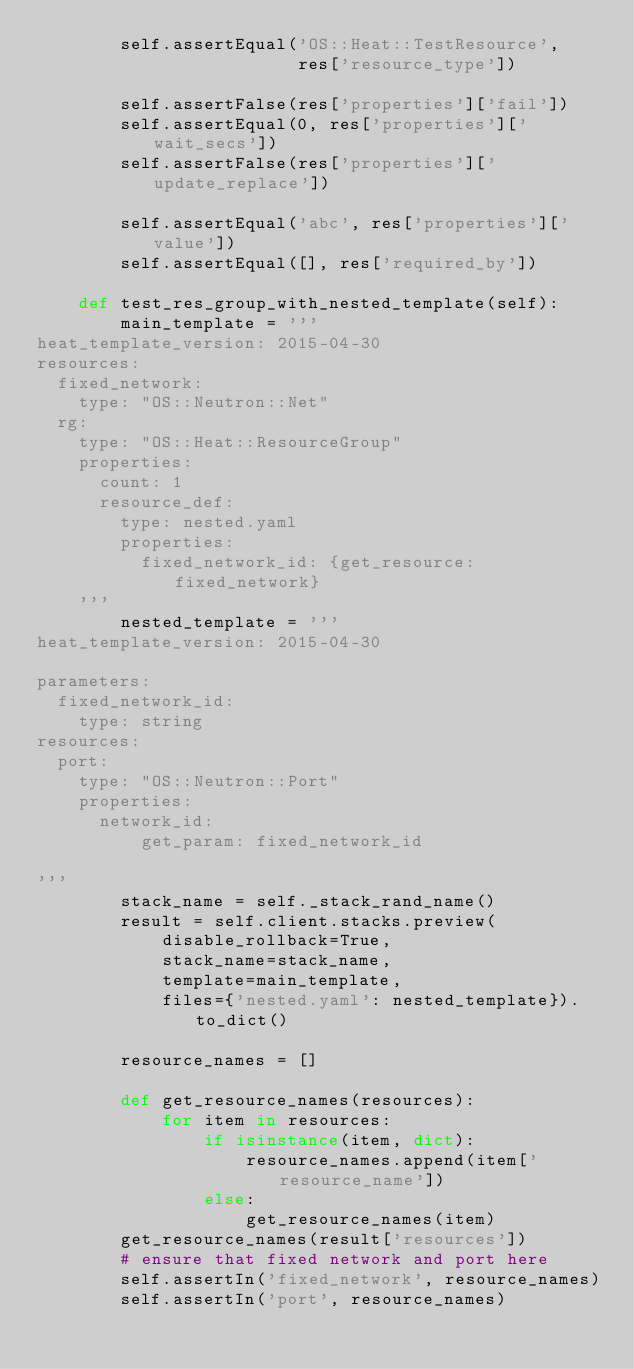Convert code to text. <code><loc_0><loc_0><loc_500><loc_500><_Python_>        self.assertEqual('OS::Heat::TestResource',
                         res['resource_type'])

        self.assertFalse(res['properties']['fail'])
        self.assertEqual(0, res['properties']['wait_secs'])
        self.assertFalse(res['properties']['update_replace'])

        self.assertEqual('abc', res['properties']['value'])
        self.assertEqual([], res['required_by'])

    def test_res_group_with_nested_template(self):
        main_template = '''
heat_template_version: 2015-04-30
resources:
  fixed_network:
    type: "OS::Neutron::Net"
  rg:
    type: "OS::Heat::ResourceGroup"
    properties:
      count: 1
      resource_def:
        type: nested.yaml
        properties:
          fixed_network_id: {get_resource: fixed_network}
    '''
        nested_template = '''
heat_template_version: 2015-04-30

parameters:
  fixed_network_id:
    type: string
resources:
  port:
    type: "OS::Neutron::Port"
    properties:
      network_id:
          get_param: fixed_network_id

'''
        stack_name = self._stack_rand_name()
        result = self.client.stacks.preview(
            disable_rollback=True,
            stack_name=stack_name,
            template=main_template,
            files={'nested.yaml': nested_template}).to_dict()

        resource_names = []

        def get_resource_names(resources):
            for item in resources:
                if isinstance(item, dict):
                    resource_names.append(item['resource_name'])
                else:
                    get_resource_names(item)
        get_resource_names(result['resources'])
        # ensure that fixed network and port here
        self.assertIn('fixed_network', resource_names)
        self.assertIn('port', resource_names)
</code> 